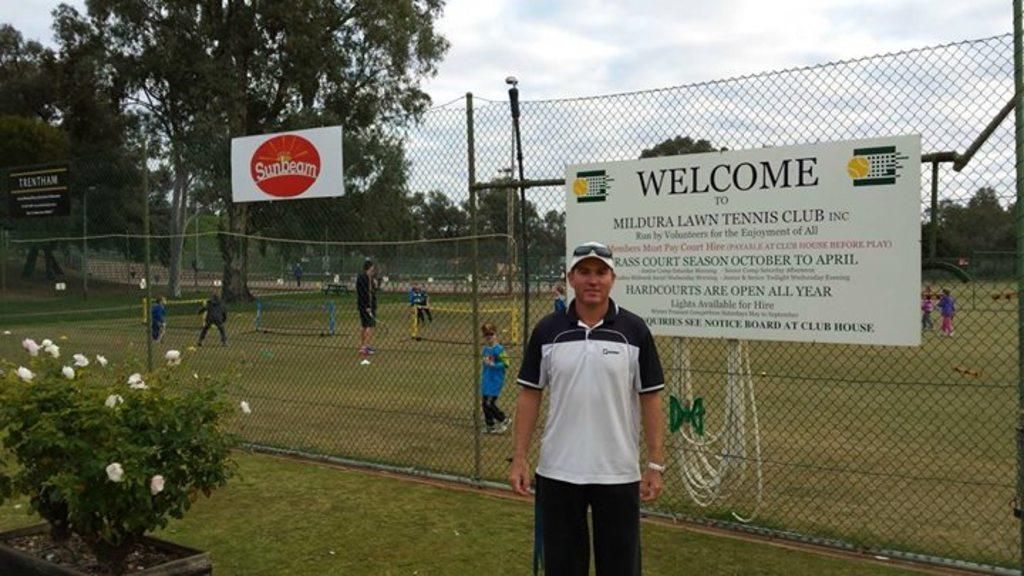<image>
Present a compact description of the photo's key features. a sign that has the word welcome on it 